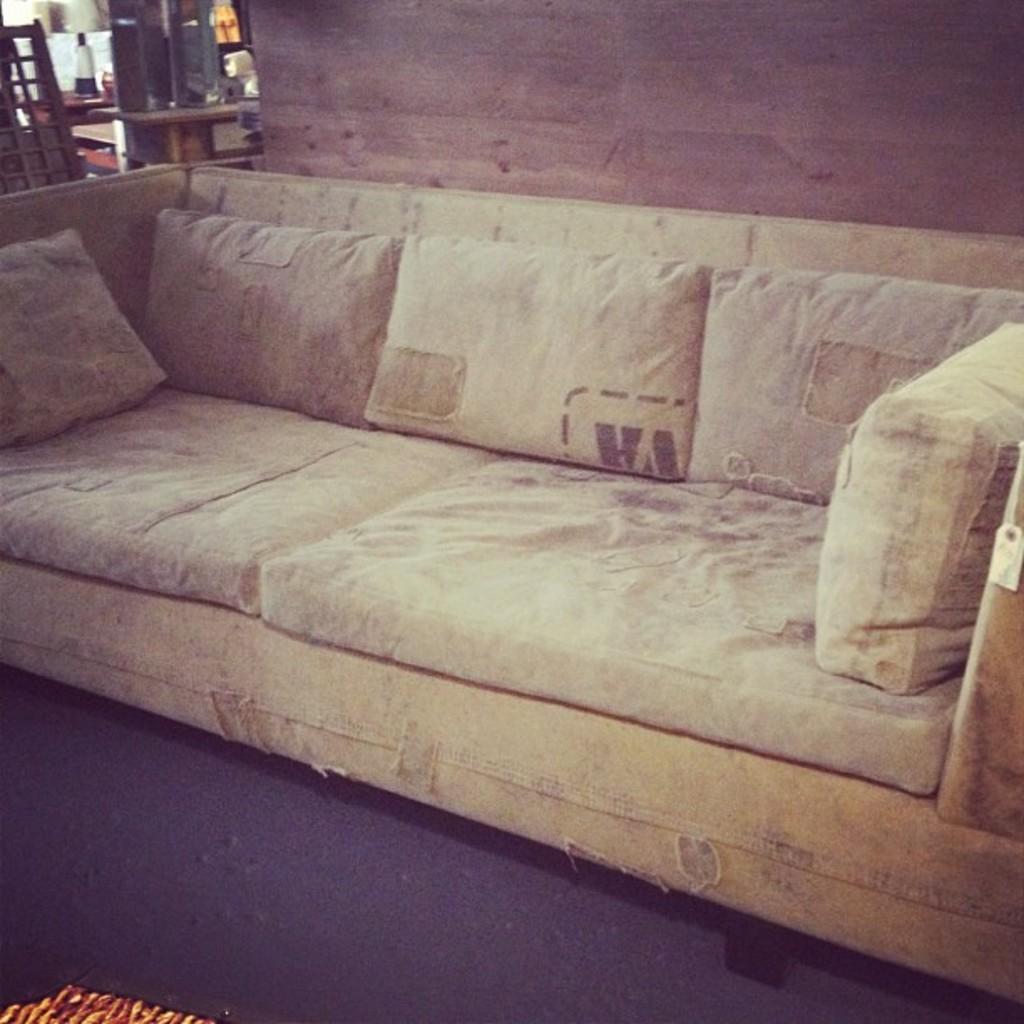Describe this image in one or two sentences. In this picture we can see a sofa in the room, and also we can find a bottle and couple of objects on the table. 